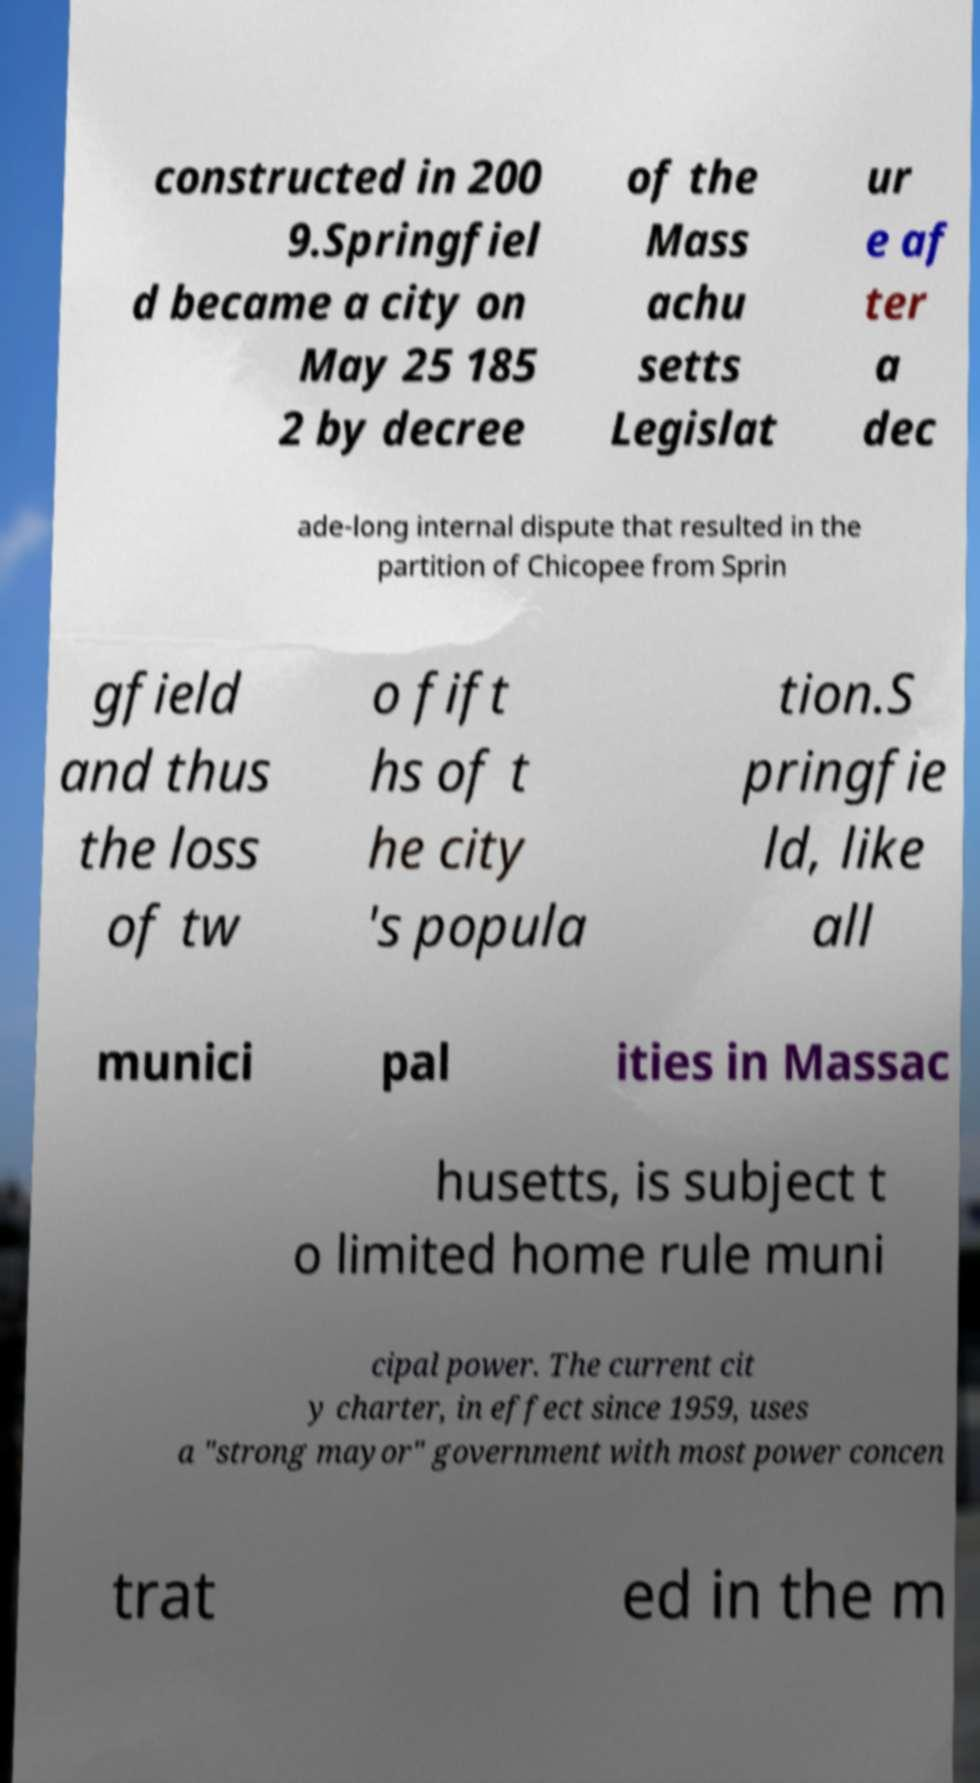What messages or text are displayed in this image? I need them in a readable, typed format. constructed in 200 9.Springfiel d became a city on May 25 185 2 by decree of the Mass achu setts Legislat ur e af ter a dec ade-long internal dispute that resulted in the partition of Chicopee from Sprin gfield and thus the loss of tw o fift hs of t he city 's popula tion.S pringfie ld, like all munici pal ities in Massac husetts, is subject t o limited home rule muni cipal power. The current cit y charter, in effect since 1959, uses a "strong mayor" government with most power concen trat ed in the m 